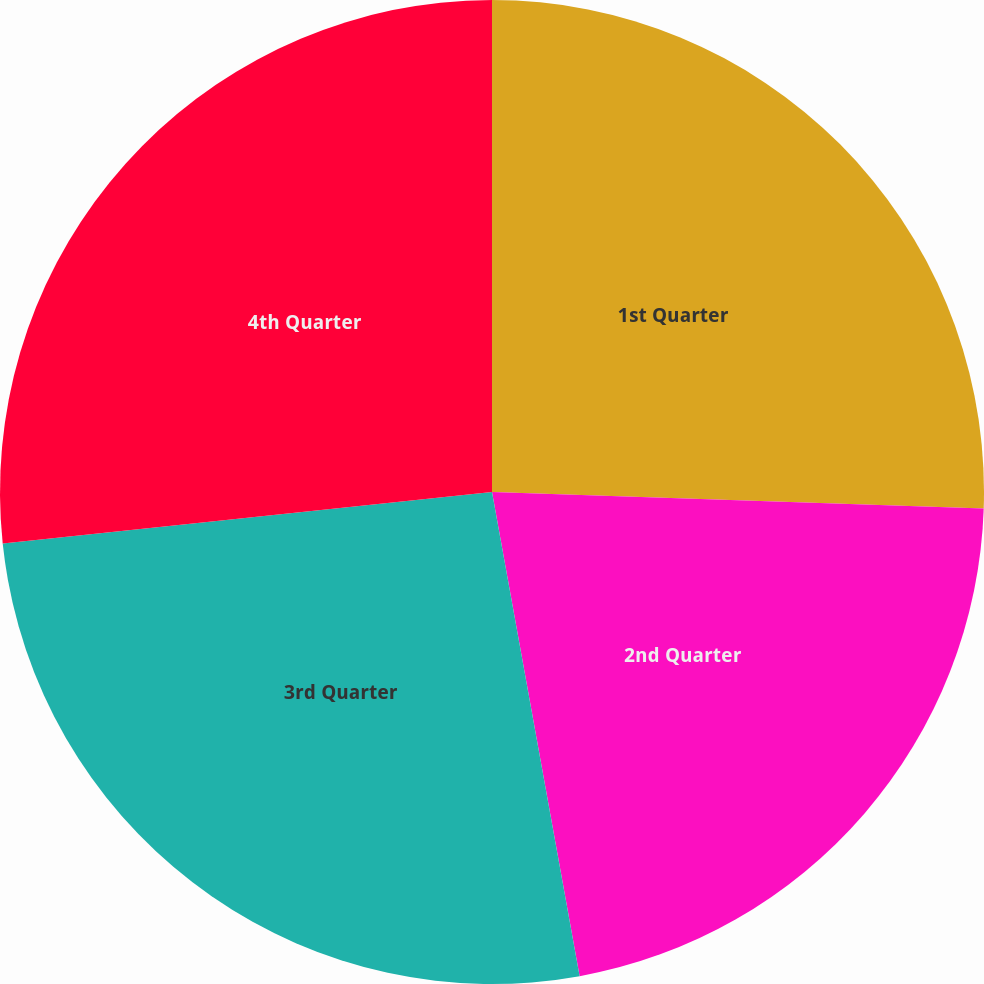<chart> <loc_0><loc_0><loc_500><loc_500><pie_chart><fcel>1st Quarter<fcel>2nd Quarter<fcel>3rd Quarter<fcel>4th Quarter<nl><fcel>25.53%<fcel>21.62%<fcel>26.18%<fcel>26.67%<nl></chart> 